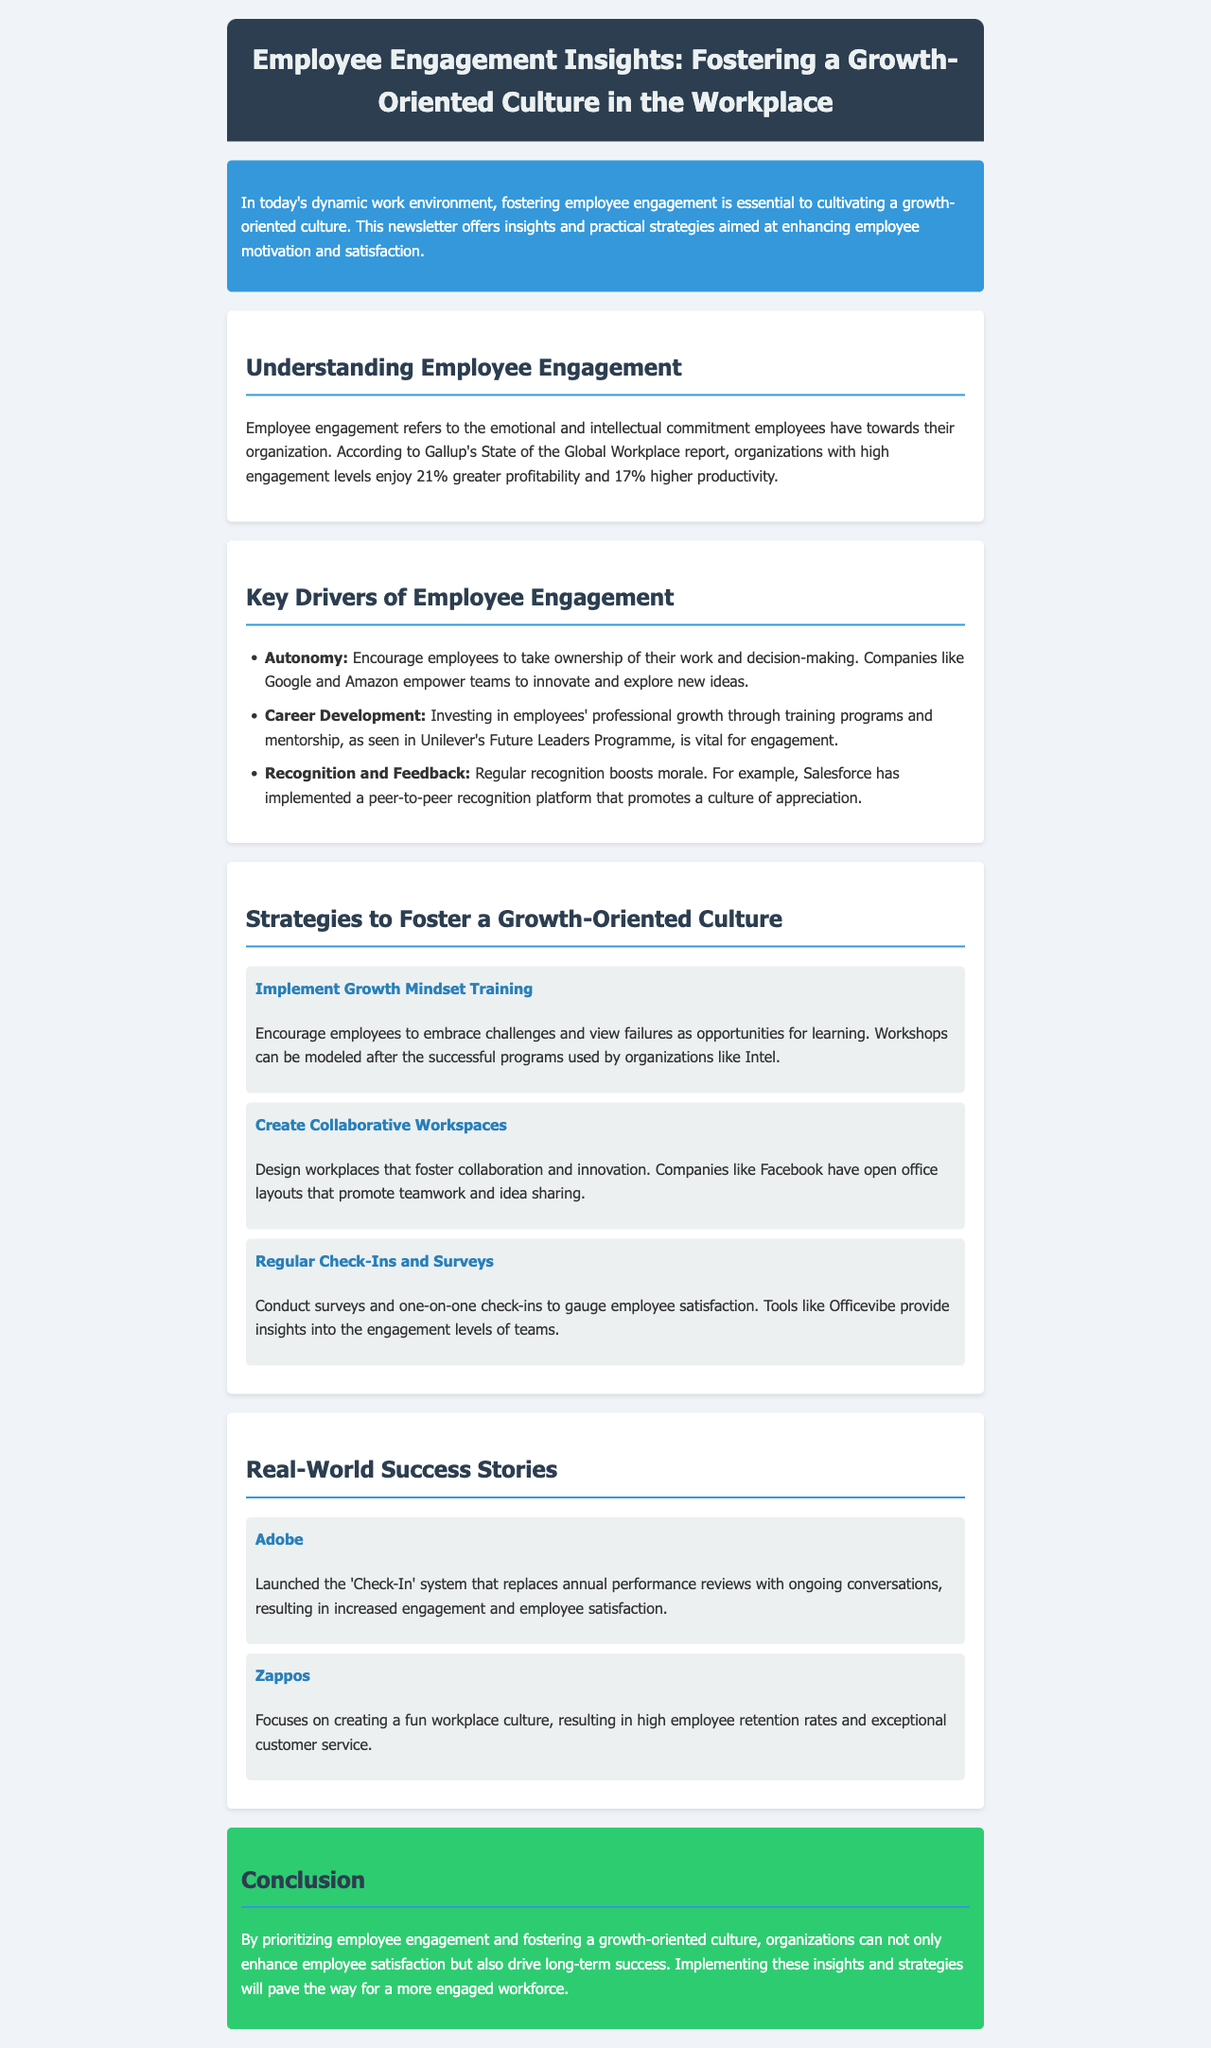What is the main topic of the newsletter? The newsletter discusses how to foster employee engagement and a growth-oriented culture in the workplace.
Answer: Employee Engagement Insights What percentage increase in profitability is associated with high employee engagement? High engagement levels reportedly lead to a 21% increase in profitability.
Answer: 21% Name one company that empowers teams to innovate. The document states that Google encourages teams to innovate.
Answer: Google What is a strategy to encourage a growth mindset in employees? The document suggests implementing growth mindset training as a strategy.
Answer: Growth Mindset Training Which company's system replaced annual performance reviews with ongoing conversations? Adobe launched the 'Check-In' system for ongoing conversations instead of annual reviews.
Answer: Adobe What tool is mentioned for conducting employee satisfaction surveys? Officevibe is a tool recommended for gauging employee engagement through surveys.
Answer: Officevibe What type of workspace design does Facebook use to foster collaboration? Facebook utilizes open office layouts to promote teamwork and idea sharing.
Answer: Open office layouts Which company focuses on creating a fun workplace culture? Zappos is noted for its focus on a fun workplace culture.
Answer: Zappos 